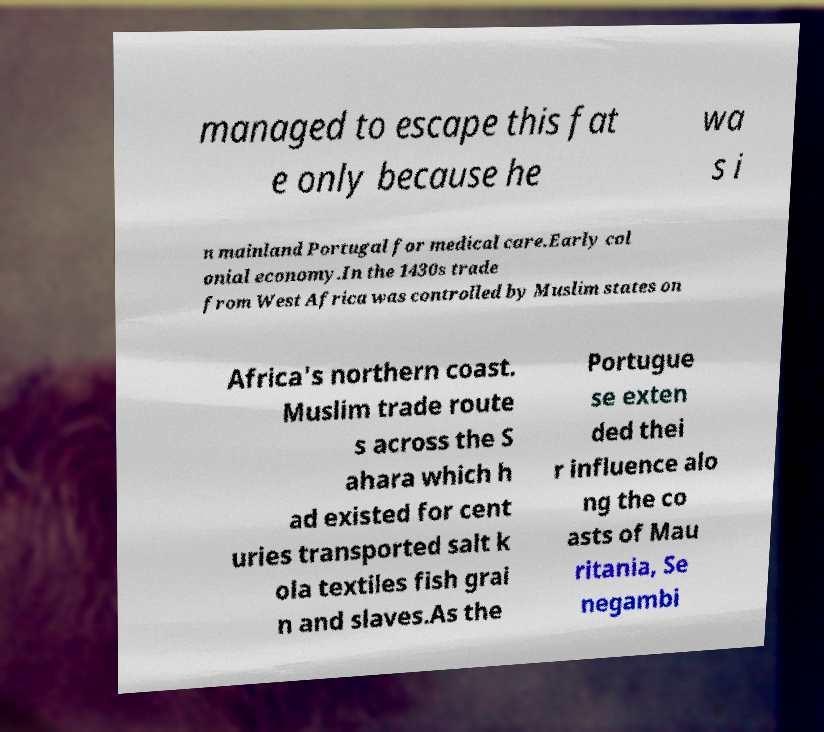Please identify and transcribe the text found in this image. managed to escape this fat e only because he wa s i n mainland Portugal for medical care.Early col onial economy.In the 1430s trade from West Africa was controlled by Muslim states on Africa's northern coast. Muslim trade route s across the S ahara which h ad existed for cent uries transported salt k ola textiles fish grai n and slaves.As the Portugue se exten ded thei r influence alo ng the co asts of Mau ritania, Se negambi 